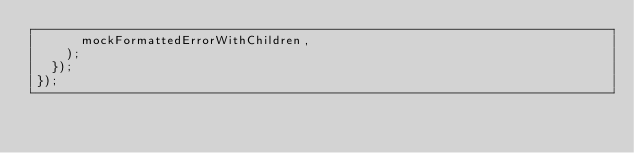<code> <loc_0><loc_0><loc_500><loc_500><_TypeScript_>      mockFormattedErrorWithChildren,
    );
  });
});
</code> 